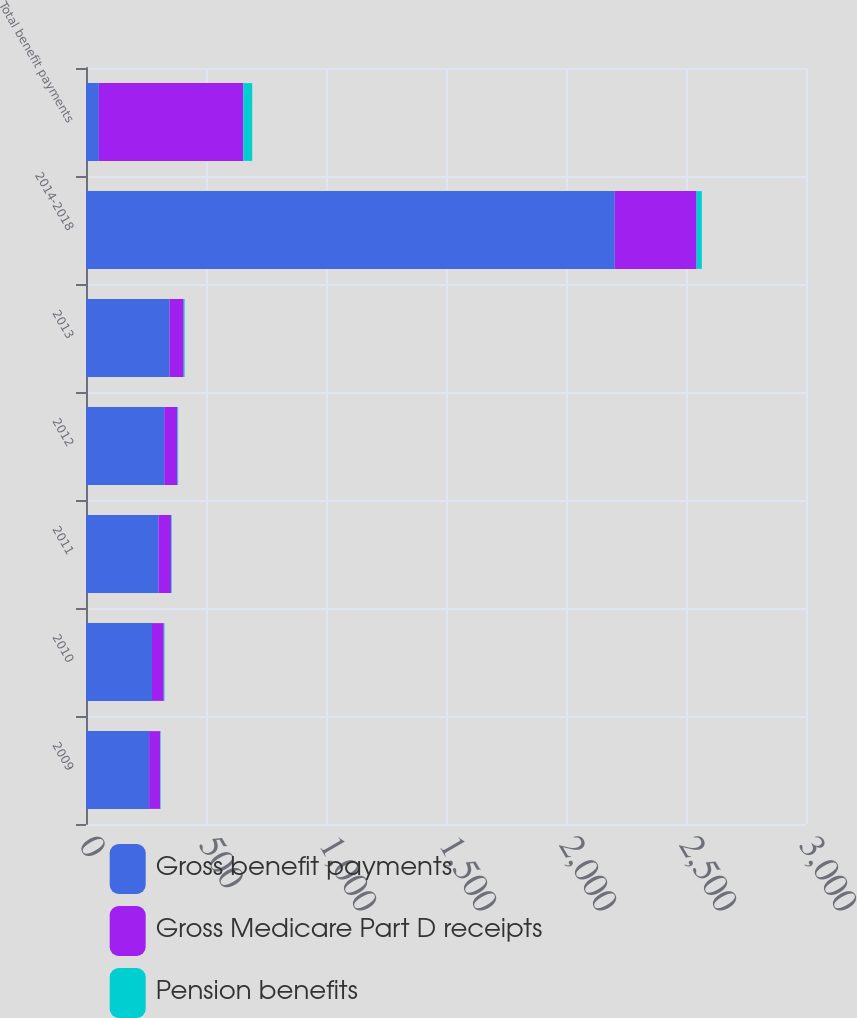Convert chart to OTSL. <chart><loc_0><loc_0><loc_500><loc_500><stacked_bar_chart><ecel><fcel>2009<fcel>2010<fcel>2011<fcel>2012<fcel>2013<fcel>2014-2018<fcel>Total benefit payments<nl><fcel>Gross benefit payments<fcel>263<fcel>275<fcel>302<fcel>326<fcel>348<fcel>2203<fcel>53.5<nl><fcel>Gross Medicare Part D receipts<fcel>46<fcel>49<fcel>52<fcel>55<fcel>59<fcel>341<fcel>602<nl><fcel>Pension benefits<fcel>2<fcel>3<fcel>3<fcel>3<fcel>4<fcel>22<fcel>37<nl></chart> 